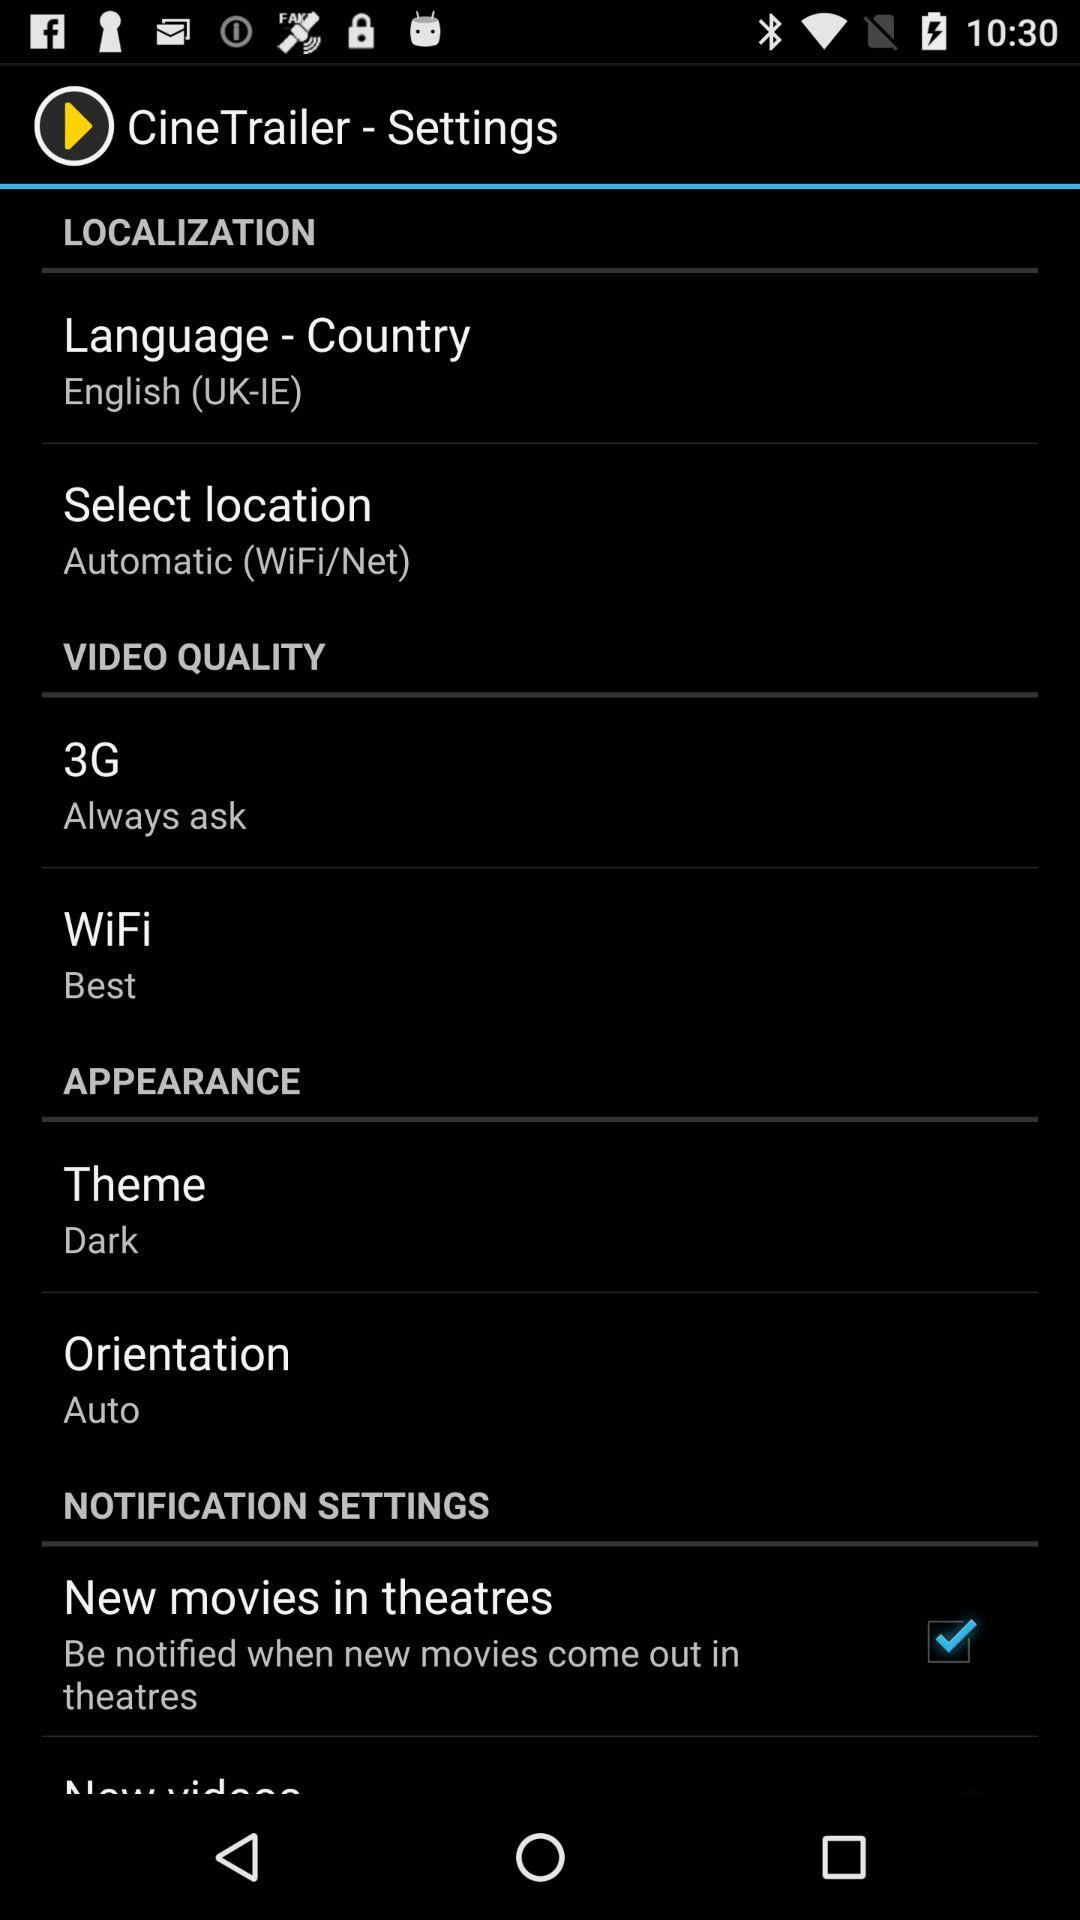What is the selected language and country? The selected language is English and the country is UK-IE. 